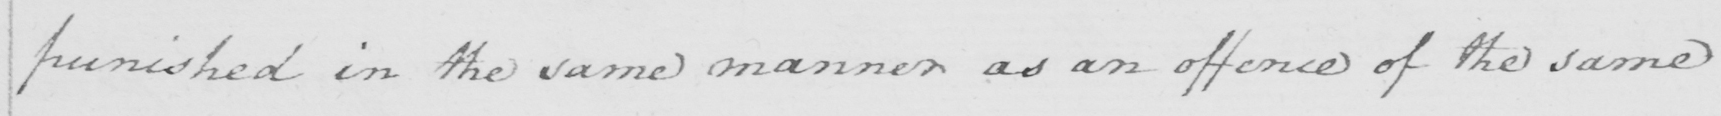Can you read and transcribe this handwriting? punished in the same manner as an offence of the same 